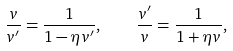<formula> <loc_0><loc_0><loc_500><loc_500>\frac { v } { v ^ { \prime } } = \frac { 1 } { 1 - \eta v ^ { \prime } } , \quad \frac { v ^ { \prime } } { v } = \frac { 1 } { 1 + \eta v } ,</formula> 